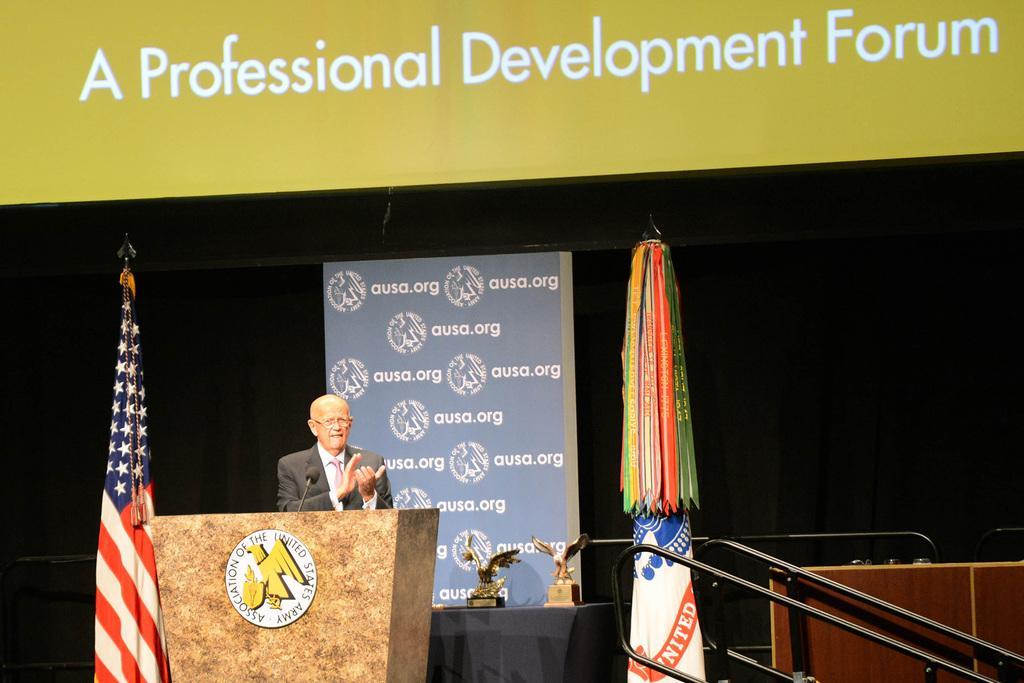How would you summarize this image in a sentence or two? In the foreground of this image, there is a man clapping hands and standing in front of a podium on which there is a mic. On either side to him, there are flags. In the background, there is a banner, few prizes on the table, railing on the right bottom and it seems like there is a screen on the top. 